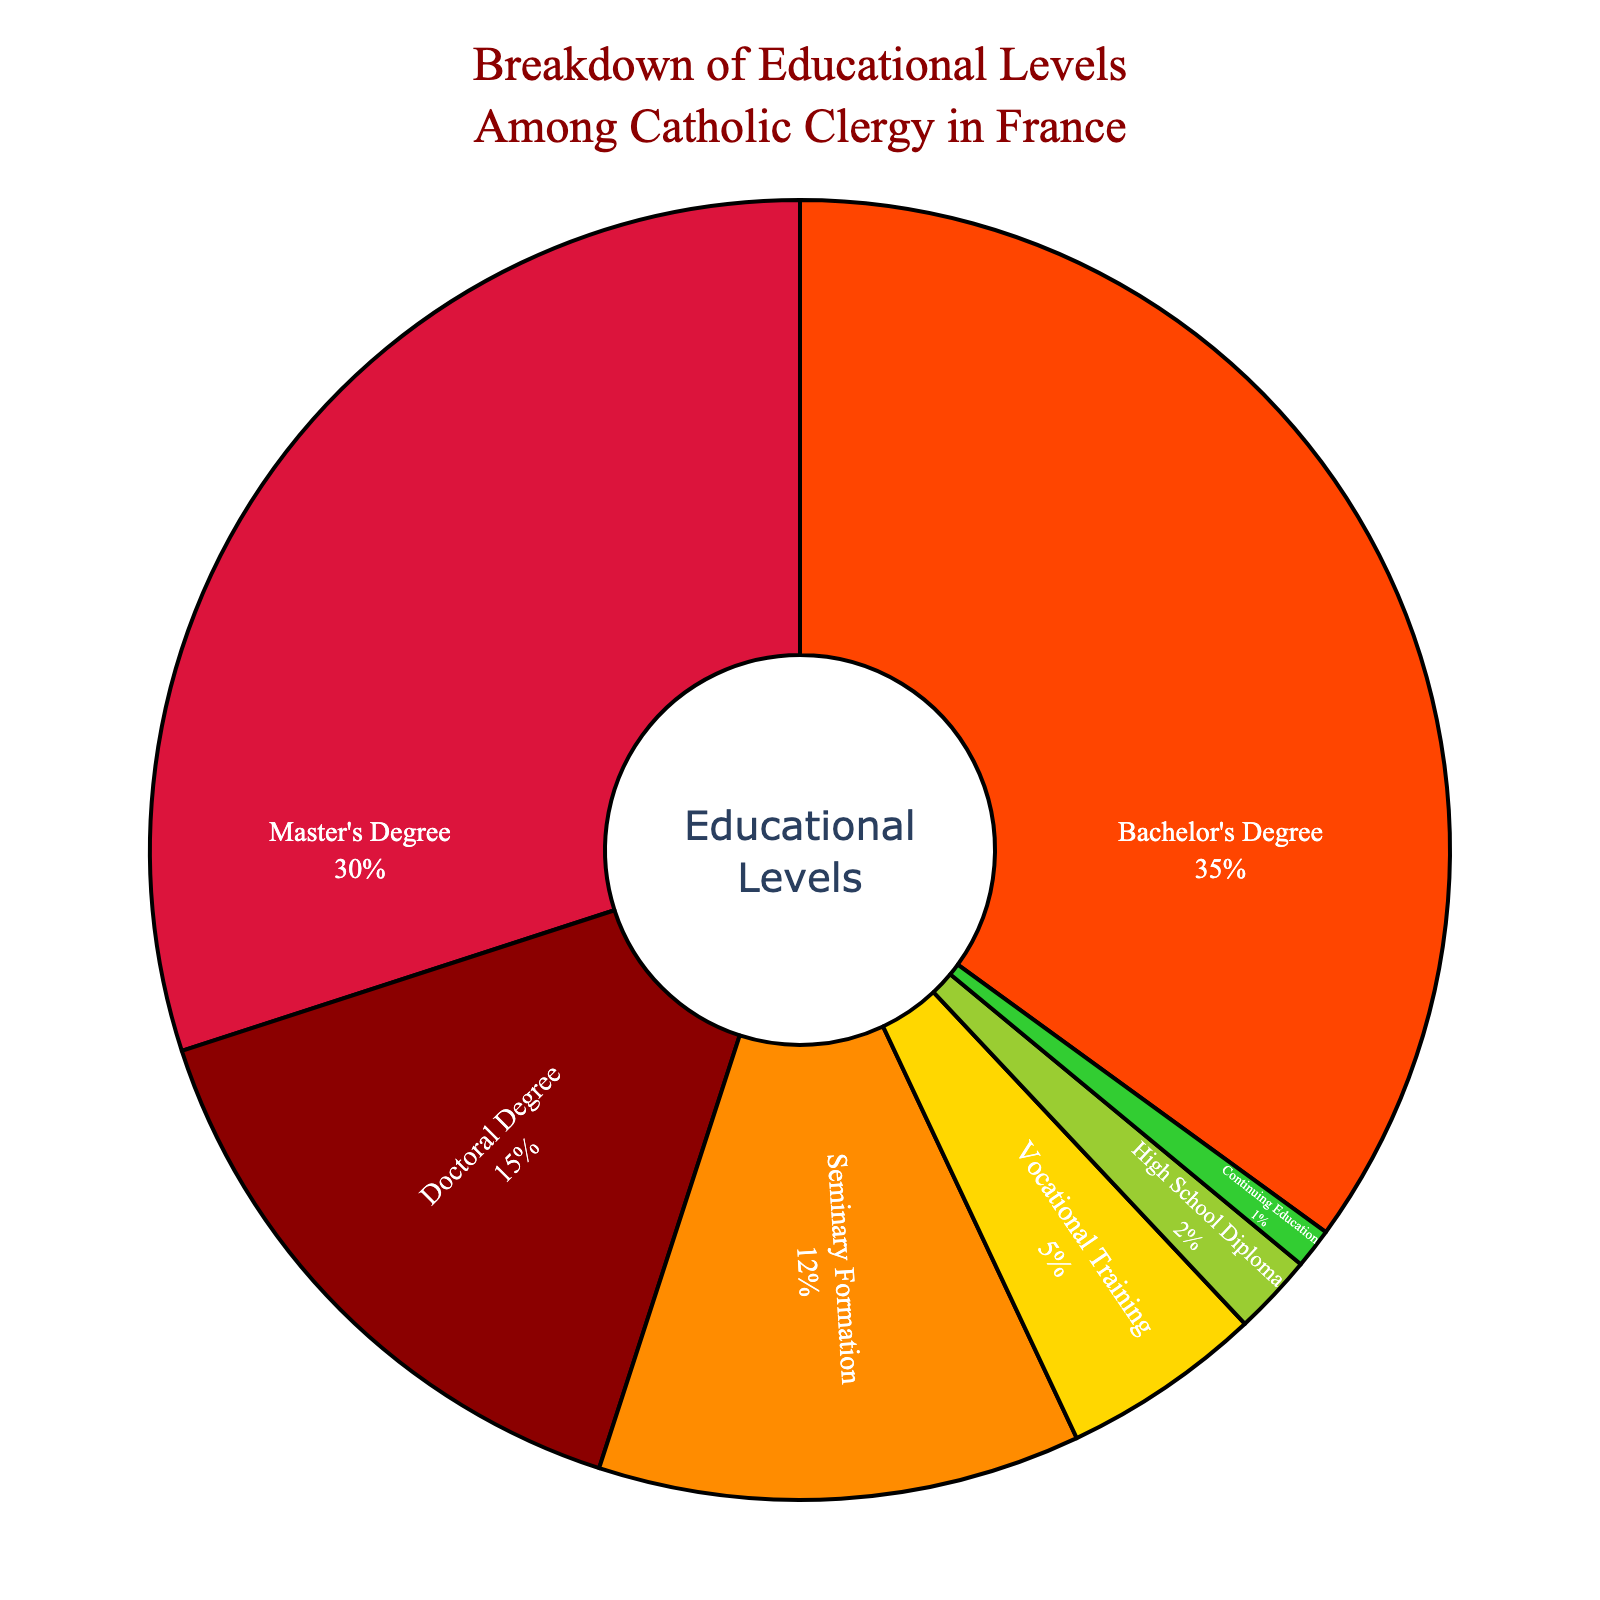What proportion of Catholic clergy have a postgraduate degree (Master's and Doctoral degrees)? To find the proportion of clergy with a postgraduate degree, sum the percentages of those holding a Master's Degree and a Doctoral Degree. Master's Degree is 30%, and Doctoral Degree is 15%. Thus, the total is 30% + 15% = 45%
Answer: 45% Which educational level has the highest representation among Catholic clergy in France? Look at the pie chart and identify the segment with the largest percentage. The Bachelor's Degree segment is the largest, representing 35%
Answer: Bachelor's Degree How does the percentage of clergy with Seminary Formation compare to those with Vocational Training? Compare the two percentages directly: Seminary Formation is 12%, whereas Vocational Training is 5%. Therefore, Seminary Formation is higher than Vocational Training by 12% - 5% = 7%
Answer: Seminary Formation is higher by 7% What is the combined percentage of clergy with the three highest educational levels (Doctoral, Master's, and Bachelor's degrees)? Add the percentages of the three highest educational levels: Doctoral Degree (15%) + Master's Degree (30%) + Bachelor's Degree (35%). The total is 15% + 30% + 35% = 80%
Answer: 80% What percentage of clergy have only a High School Diploma or Continuing Education? Sum the percentages for High School Diploma (2%) and Continuing Education (1%). The total is 2% + 1% = 3%
Answer: 3% Is the percentage of clergy with a Bachelor's Degree greater than the combined percentage of those with a High School Diploma and Vocational Training? Compare the percentage of clergy with a Bachelor's Degree (35%) to the sum of those with a High School Diploma (2%) and Vocational Training (5%), which totals 2% + 5% = 7%. The percentage with a Bachelor's Degree is indeed greater
Answer: Yes, it is greater If the pie chart had only the categories: Doctoral, Master's, and Bachelor's degrees, what would be their respective proportions relative to the new total? First, calculate the new total, which includes only Doctoral, Master's, and Bachelor's degrees: 15% + 30% + 35% = 80%. To find the new proportions, divide each percentage by the new total.
Doctoral Degree: 15% / 80% = 0.1875 or 18.75%
Master's Degree: 30% / 80% = 0.375 or 37.5%
Bachelor's Degree: 35% / 80% = 0.4375 or 43.75%
Answer: Doctoral: 18.75%, Master's: 37.5%, Bachelor's: 43.75% What is the difference in percentage between the most and least represented educational levels? The most represented educational level is Bachelor's Degree at 35%, and the least represented is Continuing Education at 1%. The difference is 35% - 1% = 34%
Answer: 34% Which segment occupies the largest portion of the pie chart, and what is its color? Observe the pie chart and identify the largest segment which is the Bachelor's Degree segment occupying 35%. The color associated with this segment is orange
Answer: Orange 